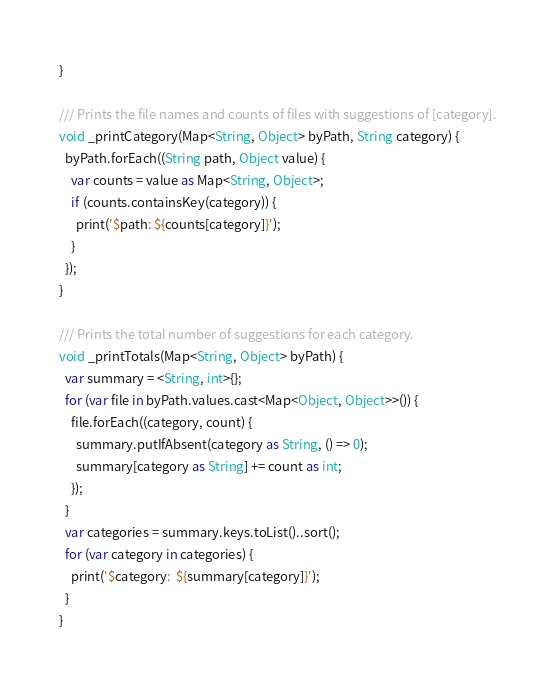Convert code to text. <code><loc_0><loc_0><loc_500><loc_500><_Dart_>}

/// Prints the file names and counts of files with suggestions of [category].
void _printCategory(Map<String, Object> byPath, String category) {
  byPath.forEach((String path, Object value) {
    var counts = value as Map<String, Object>;
    if (counts.containsKey(category)) {
      print('$path: ${counts[category]}');
    }
  });
}

/// Prints the total number of suggestions for each category.
void _printTotals(Map<String, Object> byPath) {
  var summary = <String, int>{};
  for (var file in byPath.values.cast<Map<Object, Object>>()) {
    file.forEach((category, count) {
      summary.putIfAbsent(category as String, () => 0);
      summary[category as String] += count as int;
    });
  }
  var categories = summary.keys.toList()..sort();
  for (var category in categories) {
    print('$category:  ${summary[category]}');
  }
}
</code> 